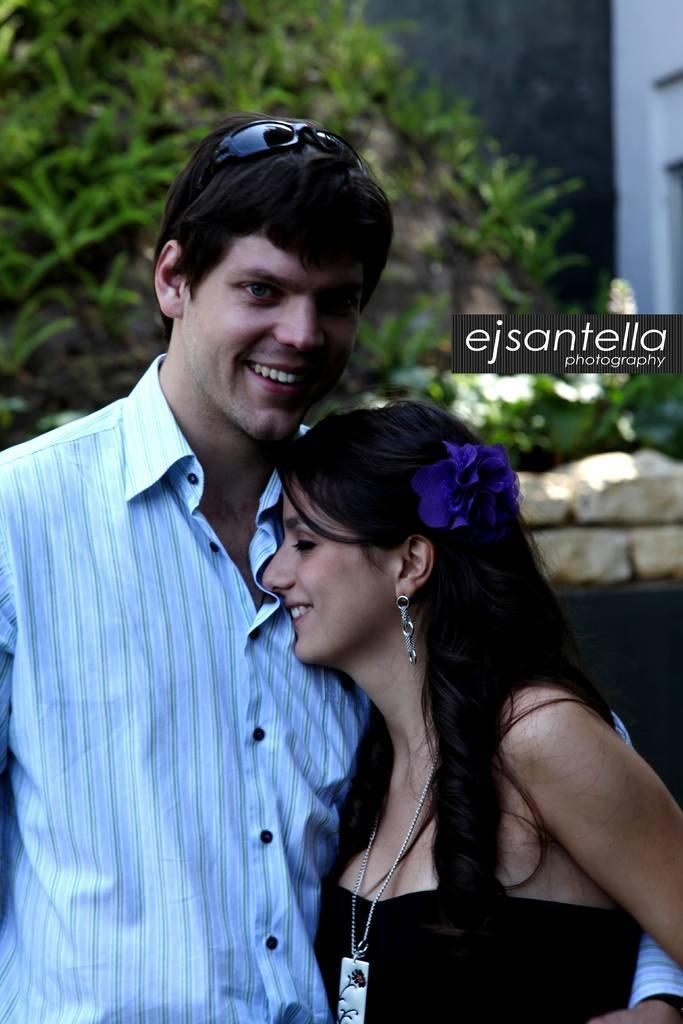In one or two sentences, can you explain what this image depicts? In this image I see a man who is wearing white shirt and I see a woman who is wearing black dress and I see that both of them are smiling and I see shades on his head and I see a violet color flower on her head and it is blurred in the background and I see the watermark over here. 